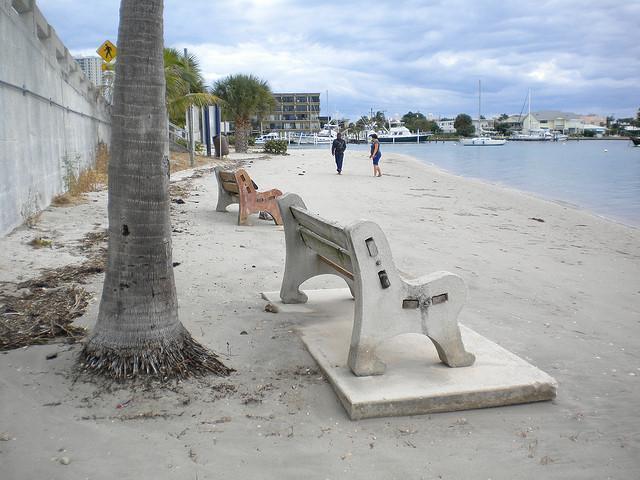What are the benches for?
Choose the right answer from the provided options to respond to the question.
Options: Washed ashore, resting, for sale, surfing. Resting. 